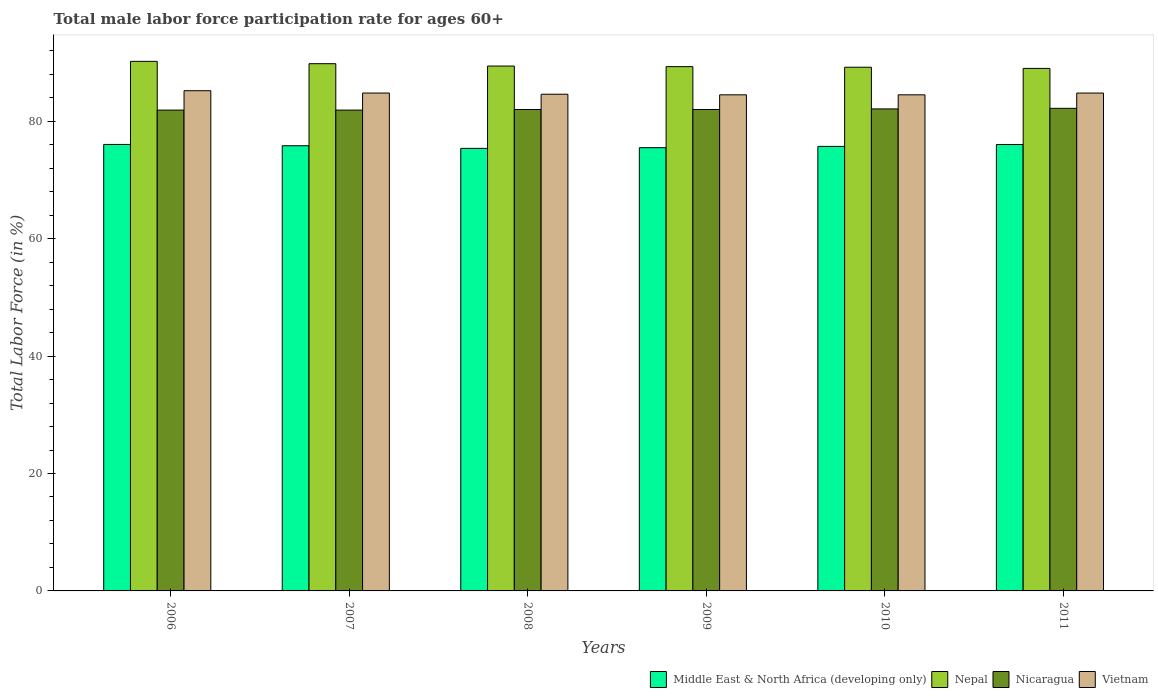How many different coloured bars are there?
Keep it short and to the point. 4. Are the number of bars per tick equal to the number of legend labels?
Offer a very short reply. Yes. How many bars are there on the 2nd tick from the left?
Provide a succinct answer. 4. In how many cases, is the number of bars for a given year not equal to the number of legend labels?
Your response must be concise. 0. What is the male labor force participation rate in Vietnam in 2011?
Your response must be concise. 84.8. Across all years, what is the maximum male labor force participation rate in Nepal?
Provide a short and direct response. 90.2. Across all years, what is the minimum male labor force participation rate in Vietnam?
Ensure brevity in your answer.  84.5. In which year was the male labor force participation rate in Vietnam maximum?
Your answer should be very brief. 2006. What is the total male labor force participation rate in Nepal in the graph?
Offer a very short reply. 536.9. What is the difference between the male labor force participation rate in Vietnam in 2008 and that in 2010?
Provide a short and direct response. 0.1. What is the difference between the male labor force participation rate in Middle East & North Africa (developing only) in 2011 and the male labor force participation rate in Nicaragua in 2007?
Your answer should be very brief. -5.87. What is the average male labor force participation rate in Nicaragua per year?
Offer a terse response. 82.02. In the year 2009, what is the difference between the male labor force participation rate in Nepal and male labor force participation rate in Vietnam?
Offer a terse response. 4.8. In how many years, is the male labor force participation rate in Nepal greater than 32 %?
Offer a very short reply. 6. What is the ratio of the male labor force participation rate in Middle East & North Africa (developing only) in 2007 to that in 2008?
Make the answer very short. 1.01. What is the difference between the highest and the second highest male labor force participation rate in Nepal?
Ensure brevity in your answer.  0.4. What is the difference between the highest and the lowest male labor force participation rate in Middle East & North Africa (developing only)?
Provide a short and direct response. 0.67. Is the sum of the male labor force participation rate in Nepal in 2008 and 2009 greater than the maximum male labor force participation rate in Vietnam across all years?
Make the answer very short. Yes. What does the 3rd bar from the left in 2007 represents?
Offer a terse response. Nicaragua. What does the 3rd bar from the right in 2007 represents?
Provide a short and direct response. Nepal. Is it the case that in every year, the sum of the male labor force participation rate in Nicaragua and male labor force participation rate in Middle East & North Africa (developing only) is greater than the male labor force participation rate in Nepal?
Offer a very short reply. Yes. Are all the bars in the graph horizontal?
Offer a very short reply. No. Does the graph contain any zero values?
Your answer should be very brief. No. Where does the legend appear in the graph?
Offer a terse response. Bottom right. How are the legend labels stacked?
Give a very brief answer. Horizontal. What is the title of the graph?
Ensure brevity in your answer.  Total male labor force participation rate for ages 60+. What is the label or title of the X-axis?
Your answer should be compact. Years. What is the label or title of the Y-axis?
Your answer should be compact. Total Labor Force (in %). What is the Total Labor Force (in %) in Middle East & North Africa (developing only) in 2006?
Ensure brevity in your answer.  76.05. What is the Total Labor Force (in %) of Nepal in 2006?
Ensure brevity in your answer.  90.2. What is the Total Labor Force (in %) in Nicaragua in 2006?
Ensure brevity in your answer.  81.9. What is the Total Labor Force (in %) of Vietnam in 2006?
Make the answer very short. 85.2. What is the Total Labor Force (in %) of Middle East & North Africa (developing only) in 2007?
Keep it short and to the point. 75.83. What is the Total Labor Force (in %) in Nepal in 2007?
Give a very brief answer. 89.8. What is the Total Labor Force (in %) of Nicaragua in 2007?
Ensure brevity in your answer.  81.9. What is the Total Labor Force (in %) in Vietnam in 2007?
Ensure brevity in your answer.  84.8. What is the Total Labor Force (in %) in Middle East & North Africa (developing only) in 2008?
Ensure brevity in your answer.  75.38. What is the Total Labor Force (in %) of Nepal in 2008?
Your response must be concise. 89.4. What is the Total Labor Force (in %) in Nicaragua in 2008?
Make the answer very short. 82. What is the Total Labor Force (in %) in Vietnam in 2008?
Ensure brevity in your answer.  84.6. What is the Total Labor Force (in %) in Middle East & North Africa (developing only) in 2009?
Give a very brief answer. 75.5. What is the Total Labor Force (in %) in Nepal in 2009?
Ensure brevity in your answer.  89.3. What is the Total Labor Force (in %) in Vietnam in 2009?
Keep it short and to the point. 84.5. What is the Total Labor Force (in %) of Middle East & North Africa (developing only) in 2010?
Your response must be concise. 75.71. What is the Total Labor Force (in %) in Nepal in 2010?
Your answer should be compact. 89.2. What is the Total Labor Force (in %) in Nicaragua in 2010?
Keep it short and to the point. 82.1. What is the Total Labor Force (in %) in Vietnam in 2010?
Offer a terse response. 84.5. What is the Total Labor Force (in %) in Middle East & North Africa (developing only) in 2011?
Your answer should be compact. 76.03. What is the Total Labor Force (in %) in Nepal in 2011?
Offer a terse response. 89. What is the Total Labor Force (in %) of Nicaragua in 2011?
Offer a terse response. 82.2. What is the Total Labor Force (in %) of Vietnam in 2011?
Your answer should be very brief. 84.8. Across all years, what is the maximum Total Labor Force (in %) of Middle East & North Africa (developing only)?
Your answer should be compact. 76.05. Across all years, what is the maximum Total Labor Force (in %) of Nepal?
Provide a short and direct response. 90.2. Across all years, what is the maximum Total Labor Force (in %) of Nicaragua?
Make the answer very short. 82.2. Across all years, what is the maximum Total Labor Force (in %) in Vietnam?
Ensure brevity in your answer.  85.2. Across all years, what is the minimum Total Labor Force (in %) in Middle East & North Africa (developing only)?
Your answer should be very brief. 75.38. Across all years, what is the minimum Total Labor Force (in %) of Nepal?
Offer a terse response. 89. Across all years, what is the minimum Total Labor Force (in %) in Nicaragua?
Offer a very short reply. 81.9. Across all years, what is the minimum Total Labor Force (in %) in Vietnam?
Give a very brief answer. 84.5. What is the total Total Labor Force (in %) of Middle East & North Africa (developing only) in the graph?
Provide a short and direct response. 454.5. What is the total Total Labor Force (in %) in Nepal in the graph?
Your response must be concise. 536.9. What is the total Total Labor Force (in %) in Nicaragua in the graph?
Your answer should be very brief. 492.1. What is the total Total Labor Force (in %) of Vietnam in the graph?
Keep it short and to the point. 508.4. What is the difference between the Total Labor Force (in %) in Middle East & North Africa (developing only) in 2006 and that in 2007?
Provide a succinct answer. 0.22. What is the difference between the Total Labor Force (in %) of Nicaragua in 2006 and that in 2007?
Offer a terse response. 0. What is the difference between the Total Labor Force (in %) of Vietnam in 2006 and that in 2007?
Ensure brevity in your answer.  0.4. What is the difference between the Total Labor Force (in %) in Middle East & North Africa (developing only) in 2006 and that in 2008?
Your answer should be compact. 0.67. What is the difference between the Total Labor Force (in %) of Nicaragua in 2006 and that in 2008?
Give a very brief answer. -0.1. What is the difference between the Total Labor Force (in %) of Middle East & North Africa (developing only) in 2006 and that in 2009?
Offer a terse response. 0.55. What is the difference between the Total Labor Force (in %) in Middle East & North Africa (developing only) in 2006 and that in 2010?
Make the answer very short. 0.34. What is the difference between the Total Labor Force (in %) in Vietnam in 2006 and that in 2010?
Your answer should be very brief. 0.7. What is the difference between the Total Labor Force (in %) in Middle East & North Africa (developing only) in 2006 and that in 2011?
Your answer should be very brief. 0.02. What is the difference between the Total Labor Force (in %) of Nepal in 2006 and that in 2011?
Provide a short and direct response. 1.2. What is the difference between the Total Labor Force (in %) of Nicaragua in 2006 and that in 2011?
Offer a terse response. -0.3. What is the difference between the Total Labor Force (in %) of Vietnam in 2006 and that in 2011?
Provide a short and direct response. 0.4. What is the difference between the Total Labor Force (in %) in Middle East & North Africa (developing only) in 2007 and that in 2008?
Your answer should be compact. 0.45. What is the difference between the Total Labor Force (in %) of Nepal in 2007 and that in 2008?
Keep it short and to the point. 0.4. What is the difference between the Total Labor Force (in %) in Middle East & North Africa (developing only) in 2007 and that in 2009?
Provide a succinct answer. 0.33. What is the difference between the Total Labor Force (in %) in Nicaragua in 2007 and that in 2009?
Your response must be concise. -0.1. What is the difference between the Total Labor Force (in %) in Middle East & North Africa (developing only) in 2007 and that in 2010?
Your response must be concise. 0.11. What is the difference between the Total Labor Force (in %) of Nepal in 2007 and that in 2010?
Offer a terse response. 0.6. What is the difference between the Total Labor Force (in %) in Middle East & North Africa (developing only) in 2007 and that in 2011?
Give a very brief answer. -0.21. What is the difference between the Total Labor Force (in %) of Nicaragua in 2007 and that in 2011?
Your response must be concise. -0.3. What is the difference between the Total Labor Force (in %) in Vietnam in 2007 and that in 2011?
Give a very brief answer. 0. What is the difference between the Total Labor Force (in %) in Middle East & North Africa (developing only) in 2008 and that in 2009?
Offer a terse response. -0.12. What is the difference between the Total Labor Force (in %) of Middle East & North Africa (developing only) in 2008 and that in 2010?
Keep it short and to the point. -0.34. What is the difference between the Total Labor Force (in %) of Nicaragua in 2008 and that in 2010?
Your response must be concise. -0.1. What is the difference between the Total Labor Force (in %) of Vietnam in 2008 and that in 2010?
Provide a short and direct response. 0.1. What is the difference between the Total Labor Force (in %) in Middle East & North Africa (developing only) in 2008 and that in 2011?
Provide a succinct answer. -0.66. What is the difference between the Total Labor Force (in %) in Nepal in 2008 and that in 2011?
Give a very brief answer. 0.4. What is the difference between the Total Labor Force (in %) in Nicaragua in 2008 and that in 2011?
Keep it short and to the point. -0.2. What is the difference between the Total Labor Force (in %) in Vietnam in 2008 and that in 2011?
Give a very brief answer. -0.2. What is the difference between the Total Labor Force (in %) in Middle East & North Africa (developing only) in 2009 and that in 2010?
Keep it short and to the point. -0.22. What is the difference between the Total Labor Force (in %) in Middle East & North Africa (developing only) in 2009 and that in 2011?
Keep it short and to the point. -0.54. What is the difference between the Total Labor Force (in %) of Nicaragua in 2009 and that in 2011?
Offer a very short reply. -0.2. What is the difference between the Total Labor Force (in %) in Vietnam in 2009 and that in 2011?
Provide a short and direct response. -0.3. What is the difference between the Total Labor Force (in %) in Middle East & North Africa (developing only) in 2010 and that in 2011?
Offer a very short reply. -0.32. What is the difference between the Total Labor Force (in %) of Middle East & North Africa (developing only) in 2006 and the Total Labor Force (in %) of Nepal in 2007?
Provide a succinct answer. -13.75. What is the difference between the Total Labor Force (in %) in Middle East & North Africa (developing only) in 2006 and the Total Labor Force (in %) in Nicaragua in 2007?
Provide a succinct answer. -5.85. What is the difference between the Total Labor Force (in %) of Middle East & North Africa (developing only) in 2006 and the Total Labor Force (in %) of Vietnam in 2007?
Ensure brevity in your answer.  -8.75. What is the difference between the Total Labor Force (in %) in Nicaragua in 2006 and the Total Labor Force (in %) in Vietnam in 2007?
Keep it short and to the point. -2.9. What is the difference between the Total Labor Force (in %) in Middle East & North Africa (developing only) in 2006 and the Total Labor Force (in %) in Nepal in 2008?
Provide a succinct answer. -13.35. What is the difference between the Total Labor Force (in %) in Middle East & North Africa (developing only) in 2006 and the Total Labor Force (in %) in Nicaragua in 2008?
Your response must be concise. -5.95. What is the difference between the Total Labor Force (in %) in Middle East & North Africa (developing only) in 2006 and the Total Labor Force (in %) in Vietnam in 2008?
Provide a short and direct response. -8.55. What is the difference between the Total Labor Force (in %) in Nepal in 2006 and the Total Labor Force (in %) in Nicaragua in 2008?
Your answer should be compact. 8.2. What is the difference between the Total Labor Force (in %) in Nepal in 2006 and the Total Labor Force (in %) in Vietnam in 2008?
Your response must be concise. 5.6. What is the difference between the Total Labor Force (in %) in Nicaragua in 2006 and the Total Labor Force (in %) in Vietnam in 2008?
Your answer should be compact. -2.7. What is the difference between the Total Labor Force (in %) of Middle East & North Africa (developing only) in 2006 and the Total Labor Force (in %) of Nepal in 2009?
Offer a terse response. -13.25. What is the difference between the Total Labor Force (in %) of Middle East & North Africa (developing only) in 2006 and the Total Labor Force (in %) of Nicaragua in 2009?
Ensure brevity in your answer.  -5.95. What is the difference between the Total Labor Force (in %) in Middle East & North Africa (developing only) in 2006 and the Total Labor Force (in %) in Vietnam in 2009?
Your answer should be very brief. -8.45. What is the difference between the Total Labor Force (in %) in Nepal in 2006 and the Total Labor Force (in %) in Nicaragua in 2009?
Your answer should be very brief. 8.2. What is the difference between the Total Labor Force (in %) of Nepal in 2006 and the Total Labor Force (in %) of Vietnam in 2009?
Ensure brevity in your answer.  5.7. What is the difference between the Total Labor Force (in %) in Middle East & North Africa (developing only) in 2006 and the Total Labor Force (in %) in Nepal in 2010?
Provide a succinct answer. -13.15. What is the difference between the Total Labor Force (in %) in Middle East & North Africa (developing only) in 2006 and the Total Labor Force (in %) in Nicaragua in 2010?
Your answer should be compact. -6.05. What is the difference between the Total Labor Force (in %) of Middle East & North Africa (developing only) in 2006 and the Total Labor Force (in %) of Vietnam in 2010?
Give a very brief answer. -8.45. What is the difference between the Total Labor Force (in %) in Nepal in 2006 and the Total Labor Force (in %) in Nicaragua in 2010?
Offer a terse response. 8.1. What is the difference between the Total Labor Force (in %) of Nepal in 2006 and the Total Labor Force (in %) of Vietnam in 2010?
Ensure brevity in your answer.  5.7. What is the difference between the Total Labor Force (in %) in Nicaragua in 2006 and the Total Labor Force (in %) in Vietnam in 2010?
Ensure brevity in your answer.  -2.6. What is the difference between the Total Labor Force (in %) in Middle East & North Africa (developing only) in 2006 and the Total Labor Force (in %) in Nepal in 2011?
Your answer should be compact. -12.95. What is the difference between the Total Labor Force (in %) of Middle East & North Africa (developing only) in 2006 and the Total Labor Force (in %) of Nicaragua in 2011?
Offer a terse response. -6.15. What is the difference between the Total Labor Force (in %) in Middle East & North Africa (developing only) in 2006 and the Total Labor Force (in %) in Vietnam in 2011?
Make the answer very short. -8.75. What is the difference between the Total Labor Force (in %) in Middle East & North Africa (developing only) in 2007 and the Total Labor Force (in %) in Nepal in 2008?
Keep it short and to the point. -13.57. What is the difference between the Total Labor Force (in %) in Middle East & North Africa (developing only) in 2007 and the Total Labor Force (in %) in Nicaragua in 2008?
Give a very brief answer. -6.17. What is the difference between the Total Labor Force (in %) of Middle East & North Africa (developing only) in 2007 and the Total Labor Force (in %) of Vietnam in 2008?
Your answer should be compact. -8.77. What is the difference between the Total Labor Force (in %) in Nicaragua in 2007 and the Total Labor Force (in %) in Vietnam in 2008?
Give a very brief answer. -2.7. What is the difference between the Total Labor Force (in %) in Middle East & North Africa (developing only) in 2007 and the Total Labor Force (in %) in Nepal in 2009?
Provide a short and direct response. -13.47. What is the difference between the Total Labor Force (in %) in Middle East & North Africa (developing only) in 2007 and the Total Labor Force (in %) in Nicaragua in 2009?
Provide a short and direct response. -6.17. What is the difference between the Total Labor Force (in %) of Middle East & North Africa (developing only) in 2007 and the Total Labor Force (in %) of Vietnam in 2009?
Ensure brevity in your answer.  -8.67. What is the difference between the Total Labor Force (in %) in Middle East & North Africa (developing only) in 2007 and the Total Labor Force (in %) in Nepal in 2010?
Make the answer very short. -13.37. What is the difference between the Total Labor Force (in %) of Middle East & North Africa (developing only) in 2007 and the Total Labor Force (in %) of Nicaragua in 2010?
Your answer should be compact. -6.27. What is the difference between the Total Labor Force (in %) of Middle East & North Africa (developing only) in 2007 and the Total Labor Force (in %) of Vietnam in 2010?
Your answer should be compact. -8.67. What is the difference between the Total Labor Force (in %) in Nepal in 2007 and the Total Labor Force (in %) in Nicaragua in 2010?
Provide a succinct answer. 7.7. What is the difference between the Total Labor Force (in %) of Nepal in 2007 and the Total Labor Force (in %) of Vietnam in 2010?
Give a very brief answer. 5.3. What is the difference between the Total Labor Force (in %) in Middle East & North Africa (developing only) in 2007 and the Total Labor Force (in %) in Nepal in 2011?
Make the answer very short. -13.17. What is the difference between the Total Labor Force (in %) of Middle East & North Africa (developing only) in 2007 and the Total Labor Force (in %) of Nicaragua in 2011?
Provide a short and direct response. -6.37. What is the difference between the Total Labor Force (in %) of Middle East & North Africa (developing only) in 2007 and the Total Labor Force (in %) of Vietnam in 2011?
Provide a short and direct response. -8.97. What is the difference between the Total Labor Force (in %) in Nepal in 2007 and the Total Labor Force (in %) in Nicaragua in 2011?
Your response must be concise. 7.6. What is the difference between the Total Labor Force (in %) of Nicaragua in 2007 and the Total Labor Force (in %) of Vietnam in 2011?
Make the answer very short. -2.9. What is the difference between the Total Labor Force (in %) of Middle East & North Africa (developing only) in 2008 and the Total Labor Force (in %) of Nepal in 2009?
Give a very brief answer. -13.92. What is the difference between the Total Labor Force (in %) in Middle East & North Africa (developing only) in 2008 and the Total Labor Force (in %) in Nicaragua in 2009?
Provide a succinct answer. -6.62. What is the difference between the Total Labor Force (in %) in Middle East & North Africa (developing only) in 2008 and the Total Labor Force (in %) in Vietnam in 2009?
Your response must be concise. -9.12. What is the difference between the Total Labor Force (in %) of Nepal in 2008 and the Total Labor Force (in %) of Nicaragua in 2009?
Provide a succinct answer. 7.4. What is the difference between the Total Labor Force (in %) in Nepal in 2008 and the Total Labor Force (in %) in Vietnam in 2009?
Offer a terse response. 4.9. What is the difference between the Total Labor Force (in %) of Nicaragua in 2008 and the Total Labor Force (in %) of Vietnam in 2009?
Make the answer very short. -2.5. What is the difference between the Total Labor Force (in %) of Middle East & North Africa (developing only) in 2008 and the Total Labor Force (in %) of Nepal in 2010?
Provide a succinct answer. -13.82. What is the difference between the Total Labor Force (in %) in Middle East & North Africa (developing only) in 2008 and the Total Labor Force (in %) in Nicaragua in 2010?
Your response must be concise. -6.72. What is the difference between the Total Labor Force (in %) in Middle East & North Africa (developing only) in 2008 and the Total Labor Force (in %) in Vietnam in 2010?
Make the answer very short. -9.12. What is the difference between the Total Labor Force (in %) in Nepal in 2008 and the Total Labor Force (in %) in Vietnam in 2010?
Provide a succinct answer. 4.9. What is the difference between the Total Labor Force (in %) of Middle East & North Africa (developing only) in 2008 and the Total Labor Force (in %) of Nepal in 2011?
Give a very brief answer. -13.62. What is the difference between the Total Labor Force (in %) in Middle East & North Africa (developing only) in 2008 and the Total Labor Force (in %) in Nicaragua in 2011?
Offer a very short reply. -6.82. What is the difference between the Total Labor Force (in %) of Middle East & North Africa (developing only) in 2008 and the Total Labor Force (in %) of Vietnam in 2011?
Your answer should be compact. -9.42. What is the difference between the Total Labor Force (in %) in Nepal in 2008 and the Total Labor Force (in %) in Vietnam in 2011?
Provide a short and direct response. 4.6. What is the difference between the Total Labor Force (in %) in Middle East & North Africa (developing only) in 2009 and the Total Labor Force (in %) in Nepal in 2010?
Your answer should be very brief. -13.7. What is the difference between the Total Labor Force (in %) of Middle East & North Africa (developing only) in 2009 and the Total Labor Force (in %) of Nicaragua in 2010?
Provide a short and direct response. -6.6. What is the difference between the Total Labor Force (in %) in Middle East & North Africa (developing only) in 2009 and the Total Labor Force (in %) in Vietnam in 2010?
Keep it short and to the point. -9. What is the difference between the Total Labor Force (in %) in Nepal in 2009 and the Total Labor Force (in %) in Vietnam in 2010?
Offer a very short reply. 4.8. What is the difference between the Total Labor Force (in %) in Nicaragua in 2009 and the Total Labor Force (in %) in Vietnam in 2010?
Keep it short and to the point. -2.5. What is the difference between the Total Labor Force (in %) in Middle East & North Africa (developing only) in 2009 and the Total Labor Force (in %) in Nepal in 2011?
Offer a terse response. -13.5. What is the difference between the Total Labor Force (in %) in Middle East & North Africa (developing only) in 2009 and the Total Labor Force (in %) in Nicaragua in 2011?
Your answer should be very brief. -6.7. What is the difference between the Total Labor Force (in %) of Middle East & North Africa (developing only) in 2009 and the Total Labor Force (in %) of Vietnam in 2011?
Provide a short and direct response. -9.3. What is the difference between the Total Labor Force (in %) of Nepal in 2009 and the Total Labor Force (in %) of Nicaragua in 2011?
Provide a succinct answer. 7.1. What is the difference between the Total Labor Force (in %) of Nicaragua in 2009 and the Total Labor Force (in %) of Vietnam in 2011?
Offer a terse response. -2.8. What is the difference between the Total Labor Force (in %) of Middle East & North Africa (developing only) in 2010 and the Total Labor Force (in %) of Nepal in 2011?
Give a very brief answer. -13.29. What is the difference between the Total Labor Force (in %) in Middle East & North Africa (developing only) in 2010 and the Total Labor Force (in %) in Nicaragua in 2011?
Make the answer very short. -6.49. What is the difference between the Total Labor Force (in %) in Middle East & North Africa (developing only) in 2010 and the Total Labor Force (in %) in Vietnam in 2011?
Keep it short and to the point. -9.09. What is the difference between the Total Labor Force (in %) in Nepal in 2010 and the Total Labor Force (in %) in Nicaragua in 2011?
Give a very brief answer. 7. What is the difference between the Total Labor Force (in %) in Nepal in 2010 and the Total Labor Force (in %) in Vietnam in 2011?
Make the answer very short. 4.4. What is the average Total Labor Force (in %) of Middle East & North Africa (developing only) per year?
Offer a very short reply. 75.75. What is the average Total Labor Force (in %) in Nepal per year?
Provide a short and direct response. 89.48. What is the average Total Labor Force (in %) of Nicaragua per year?
Make the answer very short. 82.02. What is the average Total Labor Force (in %) in Vietnam per year?
Your answer should be compact. 84.73. In the year 2006, what is the difference between the Total Labor Force (in %) in Middle East & North Africa (developing only) and Total Labor Force (in %) in Nepal?
Provide a short and direct response. -14.15. In the year 2006, what is the difference between the Total Labor Force (in %) in Middle East & North Africa (developing only) and Total Labor Force (in %) in Nicaragua?
Your response must be concise. -5.85. In the year 2006, what is the difference between the Total Labor Force (in %) of Middle East & North Africa (developing only) and Total Labor Force (in %) of Vietnam?
Offer a terse response. -9.15. In the year 2006, what is the difference between the Total Labor Force (in %) of Nicaragua and Total Labor Force (in %) of Vietnam?
Your answer should be compact. -3.3. In the year 2007, what is the difference between the Total Labor Force (in %) of Middle East & North Africa (developing only) and Total Labor Force (in %) of Nepal?
Your answer should be very brief. -13.97. In the year 2007, what is the difference between the Total Labor Force (in %) in Middle East & North Africa (developing only) and Total Labor Force (in %) in Nicaragua?
Your response must be concise. -6.07. In the year 2007, what is the difference between the Total Labor Force (in %) in Middle East & North Africa (developing only) and Total Labor Force (in %) in Vietnam?
Ensure brevity in your answer.  -8.97. In the year 2007, what is the difference between the Total Labor Force (in %) in Nepal and Total Labor Force (in %) in Nicaragua?
Your answer should be compact. 7.9. In the year 2007, what is the difference between the Total Labor Force (in %) of Nepal and Total Labor Force (in %) of Vietnam?
Offer a very short reply. 5. In the year 2008, what is the difference between the Total Labor Force (in %) in Middle East & North Africa (developing only) and Total Labor Force (in %) in Nepal?
Your response must be concise. -14.02. In the year 2008, what is the difference between the Total Labor Force (in %) in Middle East & North Africa (developing only) and Total Labor Force (in %) in Nicaragua?
Ensure brevity in your answer.  -6.62. In the year 2008, what is the difference between the Total Labor Force (in %) in Middle East & North Africa (developing only) and Total Labor Force (in %) in Vietnam?
Your answer should be very brief. -9.22. In the year 2008, what is the difference between the Total Labor Force (in %) in Nicaragua and Total Labor Force (in %) in Vietnam?
Provide a short and direct response. -2.6. In the year 2009, what is the difference between the Total Labor Force (in %) of Middle East & North Africa (developing only) and Total Labor Force (in %) of Nepal?
Your response must be concise. -13.8. In the year 2009, what is the difference between the Total Labor Force (in %) in Middle East & North Africa (developing only) and Total Labor Force (in %) in Nicaragua?
Your answer should be very brief. -6.5. In the year 2009, what is the difference between the Total Labor Force (in %) in Middle East & North Africa (developing only) and Total Labor Force (in %) in Vietnam?
Keep it short and to the point. -9. In the year 2009, what is the difference between the Total Labor Force (in %) in Nepal and Total Labor Force (in %) in Nicaragua?
Keep it short and to the point. 7.3. In the year 2010, what is the difference between the Total Labor Force (in %) of Middle East & North Africa (developing only) and Total Labor Force (in %) of Nepal?
Offer a very short reply. -13.49. In the year 2010, what is the difference between the Total Labor Force (in %) in Middle East & North Africa (developing only) and Total Labor Force (in %) in Nicaragua?
Your answer should be very brief. -6.39. In the year 2010, what is the difference between the Total Labor Force (in %) of Middle East & North Africa (developing only) and Total Labor Force (in %) of Vietnam?
Give a very brief answer. -8.79. In the year 2010, what is the difference between the Total Labor Force (in %) of Nepal and Total Labor Force (in %) of Nicaragua?
Your answer should be very brief. 7.1. In the year 2011, what is the difference between the Total Labor Force (in %) in Middle East & North Africa (developing only) and Total Labor Force (in %) in Nepal?
Offer a terse response. -12.97. In the year 2011, what is the difference between the Total Labor Force (in %) of Middle East & North Africa (developing only) and Total Labor Force (in %) of Nicaragua?
Make the answer very short. -6.17. In the year 2011, what is the difference between the Total Labor Force (in %) in Middle East & North Africa (developing only) and Total Labor Force (in %) in Vietnam?
Your answer should be very brief. -8.77. In the year 2011, what is the difference between the Total Labor Force (in %) of Nepal and Total Labor Force (in %) of Nicaragua?
Keep it short and to the point. 6.8. In the year 2011, what is the difference between the Total Labor Force (in %) of Nepal and Total Labor Force (in %) of Vietnam?
Offer a terse response. 4.2. What is the ratio of the Total Labor Force (in %) of Middle East & North Africa (developing only) in 2006 to that in 2007?
Your response must be concise. 1. What is the ratio of the Total Labor Force (in %) of Nepal in 2006 to that in 2007?
Keep it short and to the point. 1. What is the ratio of the Total Labor Force (in %) in Nicaragua in 2006 to that in 2007?
Make the answer very short. 1. What is the ratio of the Total Labor Force (in %) in Vietnam in 2006 to that in 2007?
Offer a very short reply. 1. What is the ratio of the Total Labor Force (in %) in Middle East & North Africa (developing only) in 2006 to that in 2008?
Your answer should be very brief. 1.01. What is the ratio of the Total Labor Force (in %) of Nepal in 2006 to that in 2008?
Ensure brevity in your answer.  1.01. What is the ratio of the Total Labor Force (in %) in Vietnam in 2006 to that in 2008?
Give a very brief answer. 1.01. What is the ratio of the Total Labor Force (in %) in Middle East & North Africa (developing only) in 2006 to that in 2009?
Provide a succinct answer. 1.01. What is the ratio of the Total Labor Force (in %) in Nepal in 2006 to that in 2009?
Your answer should be very brief. 1.01. What is the ratio of the Total Labor Force (in %) of Nicaragua in 2006 to that in 2009?
Ensure brevity in your answer.  1. What is the ratio of the Total Labor Force (in %) in Vietnam in 2006 to that in 2009?
Give a very brief answer. 1.01. What is the ratio of the Total Labor Force (in %) in Middle East & North Africa (developing only) in 2006 to that in 2010?
Give a very brief answer. 1. What is the ratio of the Total Labor Force (in %) in Nepal in 2006 to that in 2010?
Your answer should be very brief. 1.01. What is the ratio of the Total Labor Force (in %) in Nicaragua in 2006 to that in 2010?
Your answer should be compact. 1. What is the ratio of the Total Labor Force (in %) in Vietnam in 2006 to that in 2010?
Offer a very short reply. 1.01. What is the ratio of the Total Labor Force (in %) in Nepal in 2006 to that in 2011?
Ensure brevity in your answer.  1.01. What is the ratio of the Total Labor Force (in %) of Nicaragua in 2006 to that in 2011?
Offer a terse response. 1. What is the ratio of the Total Labor Force (in %) of Middle East & North Africa (developing only) in 2007 to that in 2008?
Provide a succinct answer. 1.01. What is the ratio of the Total Labor Force (in %) of Nepal in 2007 to that in 2008?
Ensure brevity in your answer.  1. What is the ratio of the Total Labor Force (in %) in Nepal in 2007 to that in 2009?
Keep it short and to the point. 1.01. What is the ratio of the Total Labor Force (in %) in Nicaragua in 2007 to that in 2009?
Your answer should be compact. 1. What is the ratio of the Total Labor Force (in %) in Vietnam in 2007 to that in 2009?
Provide a short and direct response. 1. What is the ratio of the Total Labor Force (in %) of Middle East & North Africa (developing only) in 2007 to that in 2010?
Keep it short and to the point. 1. What is the ratio of the Total Labor Force (in %) in Nepal in 2007 to that in 2010?
Provide a succinct answer. 1.01. What is the ratio of the Total Labor Force (in %) in Vietnam in 2007 to that in 2010?
Your response must be concise. 1. What is the ratio of the Total Labor Force (in %) in Vietnam in 2007 to that in 2011?
Give a very brief answer. 1. What is the ratio of the Total Labor Force (in %) in Vietnam in 2008 to that in 2009?
Provide a succinct answer. 1. What is the ratio of the Total Labor Force (in %) of Vietnam in 2008 to that in 2010?
Offer a very short reply. 1. What is the ratio of the Total Labor Force (in %) in Nepal in 2008 to that in 2011?
Offer a terse response. 1. What is the ratio of the Total Labor Force (in %) of Vietnam in 2008 to that in 2011?
Give a very brief answer. 1. What is the ratio of the Total Labor Force (in %) of Nicaragua in 2009 to that in 2010?
Your response must be concise. 1. What is the ratio of the Total Labor Force (in %) of Middle East & North Africa (developing only) in 2009 to that in 2011?
Ensure brevity in your answer.  0.99. What is the ratio of the Total Labor Force (in %) in Middle East & North Africa (developing only) in 2010 to that in 2011?
Ensure brevity in your answer.  1. What is the ratio of the Total Labor Force (in %) of Nepal in 2010 to that in 2011?
Ensure brevity in your answer.  1. What is the ratio of the Total Labor Force (in %) of Vietnam in 2010 to that in 2011?
Provide a succinct answer. 1. What is the difference between the highest and the second highest Total Labor Force (in %) in Middle East & North Africa (developing only)?
Ensure brevity in your answer.  0.02. What is the difference between the highest and the second highest Total Labor Force (in %) of Nepal?
Your answer should be very brief. 0.4. What is the difference between the highest and the lowest Total Labor Force (in %) of Middle East & North Africa (developing only)?
Your response must be concise. 0.67. What is the difference between the highest and the lowest Total Labor Force (in %) in Nicaragua?
Keep it short and to the point. 0.3. 